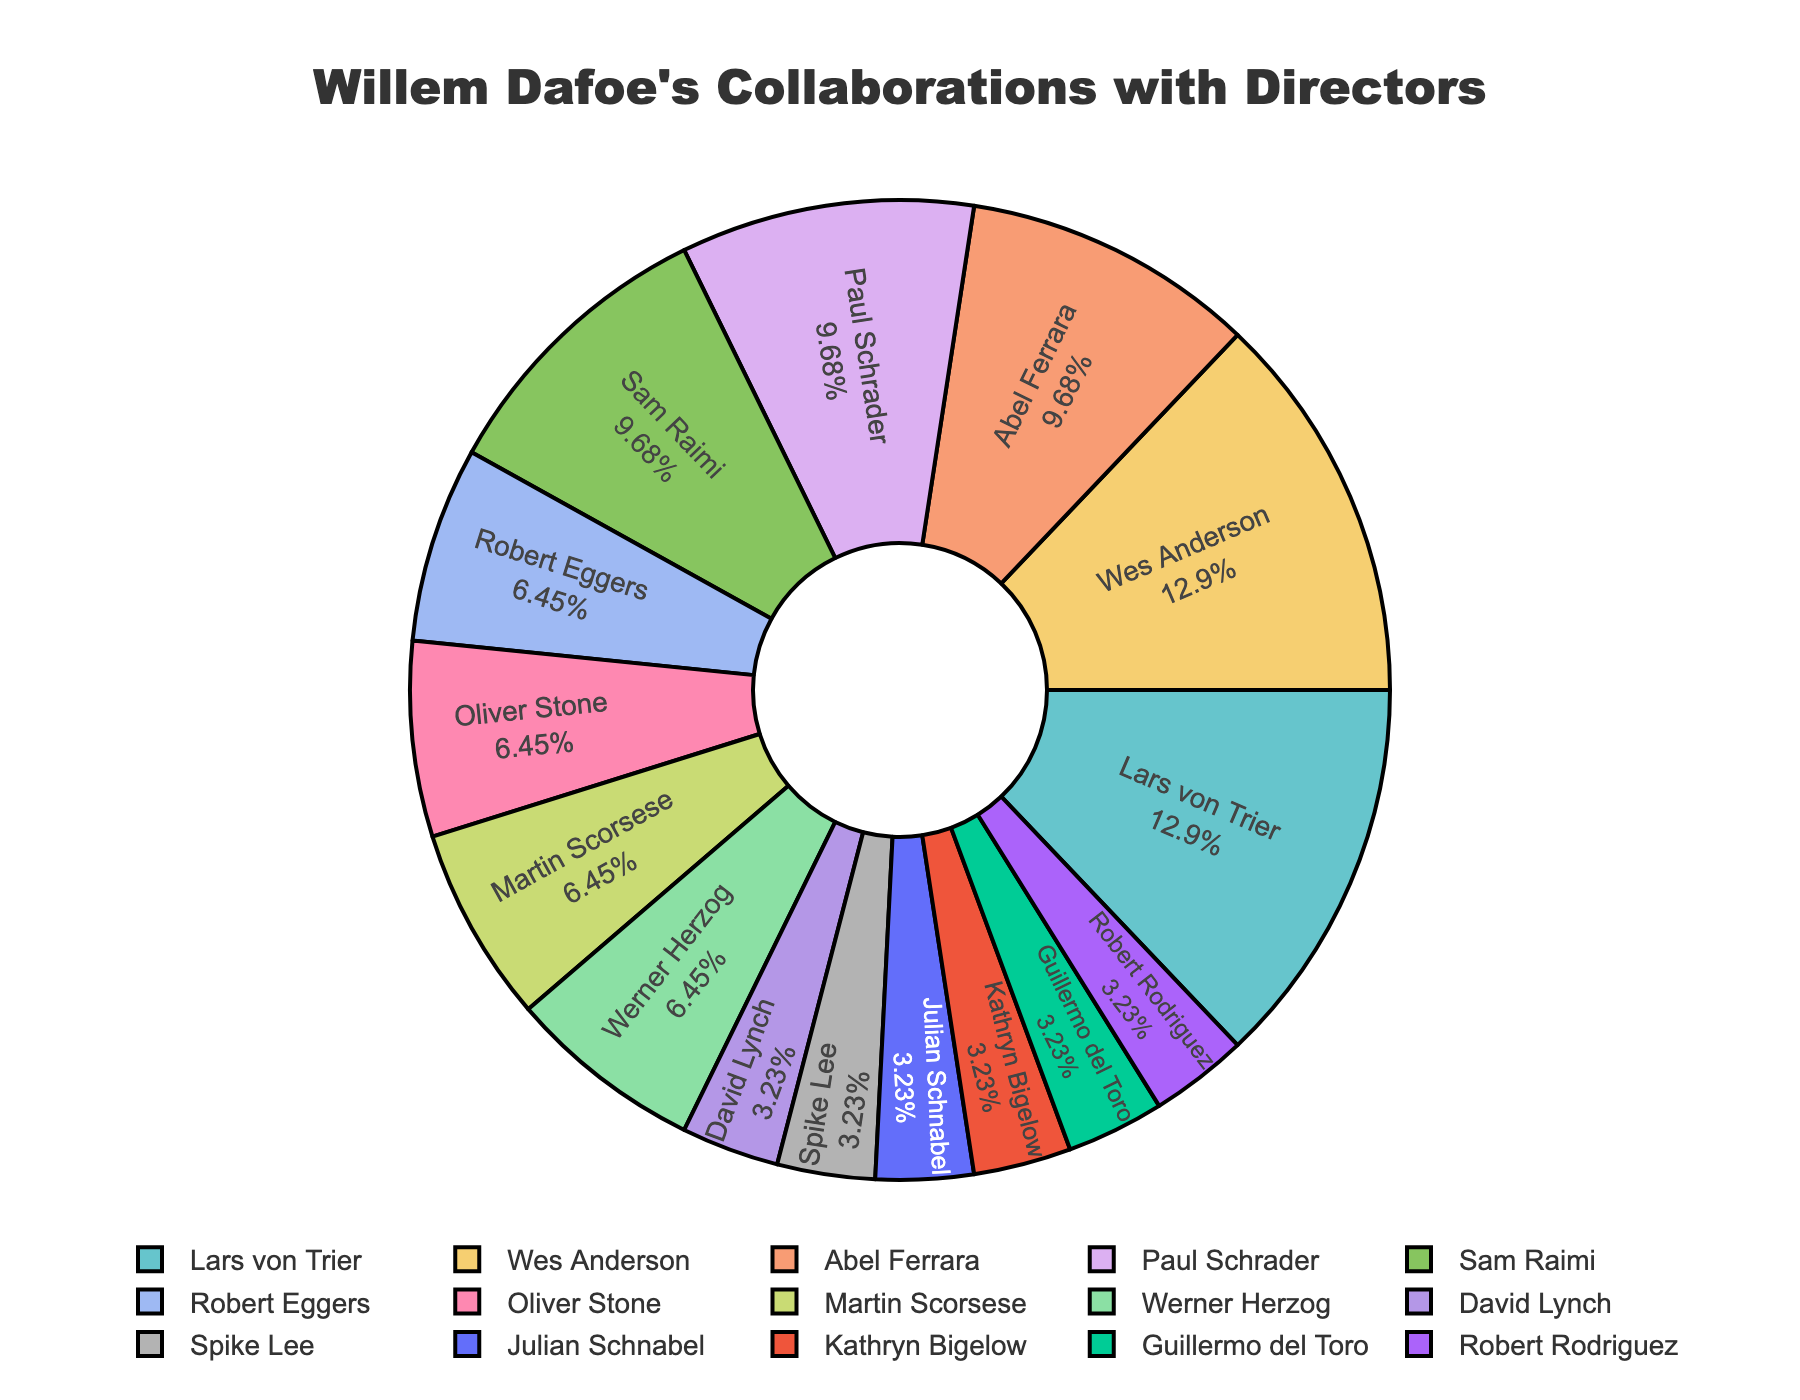Which directors has Willem Dafoe collaborated with the most? In the pie chart, we look for the largest slices to determine the directors with whom Dafoe has collaborated the most. Both Lars von Trier and Wes Anderson have the largest sections.
Answer: Lars von Trier and Wes Anderson How many films has Willem Dafoe done with Sam Raimi compared to Robert Eggers? Count the films for each director by looking at the size of the slices labeled for Sam Raimi and Robert Eggers. Sam Raimi has 3 and Robert Eggers has 2.
Answer: 3 compared to 2 What's the combined percentage of Willem Dafoe's collaborations with Lars von Trier and Wes Anderson? Identify the slices for Lars von Trier and Wes Anderson, and then sum their individual percentages as shown in the pie chart. Assume each has roughly an equal share, and each slice reports percentages based on the data's values.
Answer: Approximately 24.39% Which directors has Willem Dafoe collaborated with only once? Look for the smallest slices in the pie chart, each representing a single film. These directors will be David Lynch, Spike Lee, Julian Schnabel, Kathryn Bigelow, Guillermo del Toro, and Robert Rodriguez.
Answer: David Lynch, Spike Lee, Julian Schnabel, Kathryn Bigelow, Guillermo del Toro, Robert Rodriguez Does Willem Dafoe have more collaborations with Wes Anderson or Oliver Stone and Werner Herzog combined? Compare the slice for Wes Anderson (4 films) to the combined slices of Oliver Stone and Werner Herzog, each with 2 films (totaling 4 films). They are equal in this case.
Answer: They are equal What is the total number of films Willem Dafoe has done with Lars von Trier, Wes Anderson, and Abel Ferrara? Add the number of films for each director: Lars von Trier (4), Wes Anderson (4), and Abel Ferrara (3). Therefore, 4 + 4 + 3 = 11.
Answer: 11 How many directors has Willem Dafoe collaborated with at least three times? Look at the pie chart and count the directors with 3 or more films: Lars von Trier, Wes Anderson, Abel Ferrara, Paul Schrader, and Sam Raimi.
Answer: 5 directors Compare the number of films Willem Dafoe did with Guillermo del Toro and Robert Rodriguez to the number with Martin Scorsese. Guillermo del Toro and Robert Rodriguez each have 1 film, totaling 2. Martin Scorsese has 2 films. Thus, their quantities are equal.
Answer: Equal, 2 films each What's the total percentage of Willem Dafoe's collaborations with Kathryn Bigelow, Julian Schnabel, and David Lynch? Identify the slices for these directors, each representing 1 film. The percentages add up to the total percentage of films for these three directors. Assume each 1-film slice is approximately 4.88%. Therefore, 4.88% + 4.88% + 4.88% = 14.64%.
Answer: 14.64% 